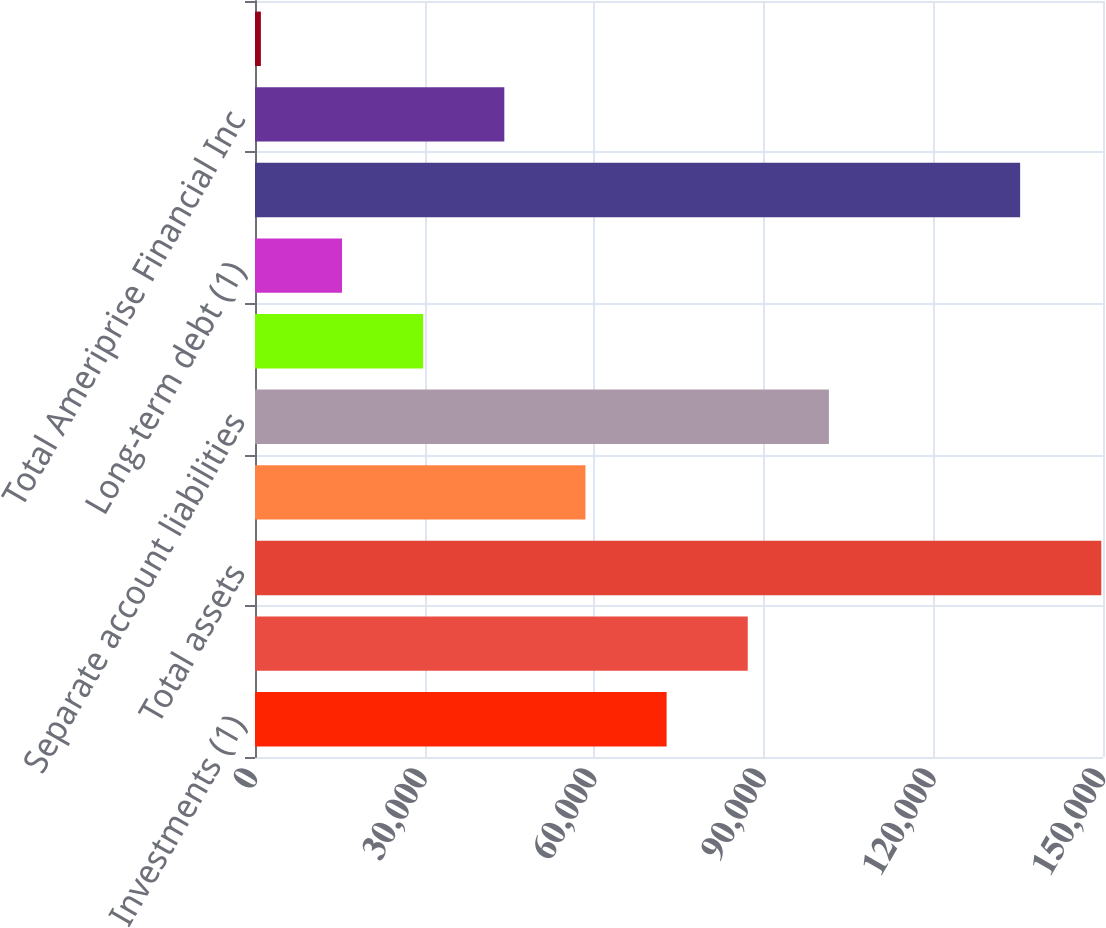Convert chart to OTSL. <chart><loc_0><loc_0><loc_500><loc_500><bar_chart><fcel>Investments (1)<fcel>Separate account assets<fcel>Total assets<fcel>Policyholder account balances<fcel>Separate account liabilities<fcel>Customer deposits<fcel>Long-term debt (1)<fcel>Total liabilities<fcel>Total Ameriprise Financial Inc<fcel>Noncontrolling interests'<nl><fcel>72808<fcel>87161.6<fcel>149698<fcel>58454.4<fcel>101515<fcel>29747.2<fcel>15393.6<fcel>135344<fcel>44100.8<fcel>1040<nl></chart> 